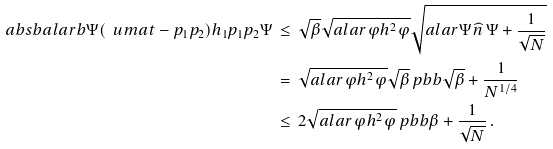Convert formula to latex. <formula><loc_0><loc_0><loc_500><loc_500>\ a b s b { a l a r b { \Psi } { ( \ u m a t - p _ { 1 } p _ { 2 } ) h _ { 1 } p _ { 1 } p _ { 2 } \Psi } } & \, \leq \, \sqrt { \beta } \sqrt { a l a r { \varphi } { h ^ { 2 } \varphi } } \sqrt { a l a r { \Psi } { \widehat { n } \, \Psi } + \frac { 1 } { \sqrt { N } } } \\ & \, = \, \sqrt { a l a r { \varphi } { h ^ { 2 } \varphi } } \sqrt { \beta } \ p b b { \sqrt { \beta } + \frac { 1 } { N ^ { 1 / 4 } } } \\ & \, \leq \, 2 \sqrt { a l a r { \varphi } { h ^ { 2 } \varphi } } \ p b b { \beta + \frac { 1 } { \sqrt { N } } } \, .</formula> 